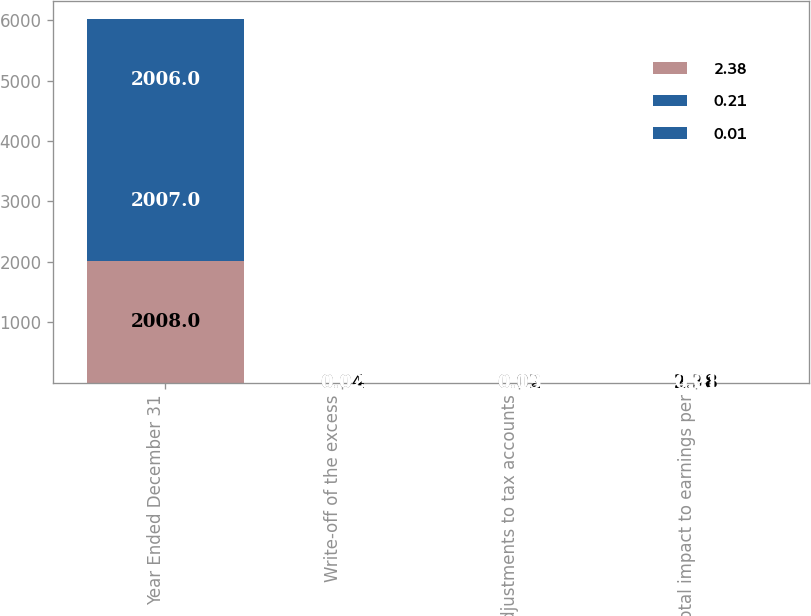Convert chart to OTSL. <chart><loc_0><loc_0><loc_500><loc_500><stacked_bar_chart><ecel><fcel>Year Ended December 31<fcel>Write-off of the excess<fcel>Adjustments to tax accounts<fcel>Total impact to earnings per<nl><fcel>2.38<fcel>2008<fcel>0.04<fcel>0.02<fcel>2.38<nl><fcel>0.21<fcel>2007<fcel>0.02<fcel>0.03<fcel>0.01<nl><fcel>0.01<fcel>2006<fcel>0.02<fcel>0.19<fcel>0.21<nl></chart> 